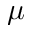<formula> <loc_0><loc_0><loc_500><loc_500>\mu</formula> 